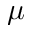<formula> <loc_0><loc_0><loc_500><loc_500>\mu</formula> 